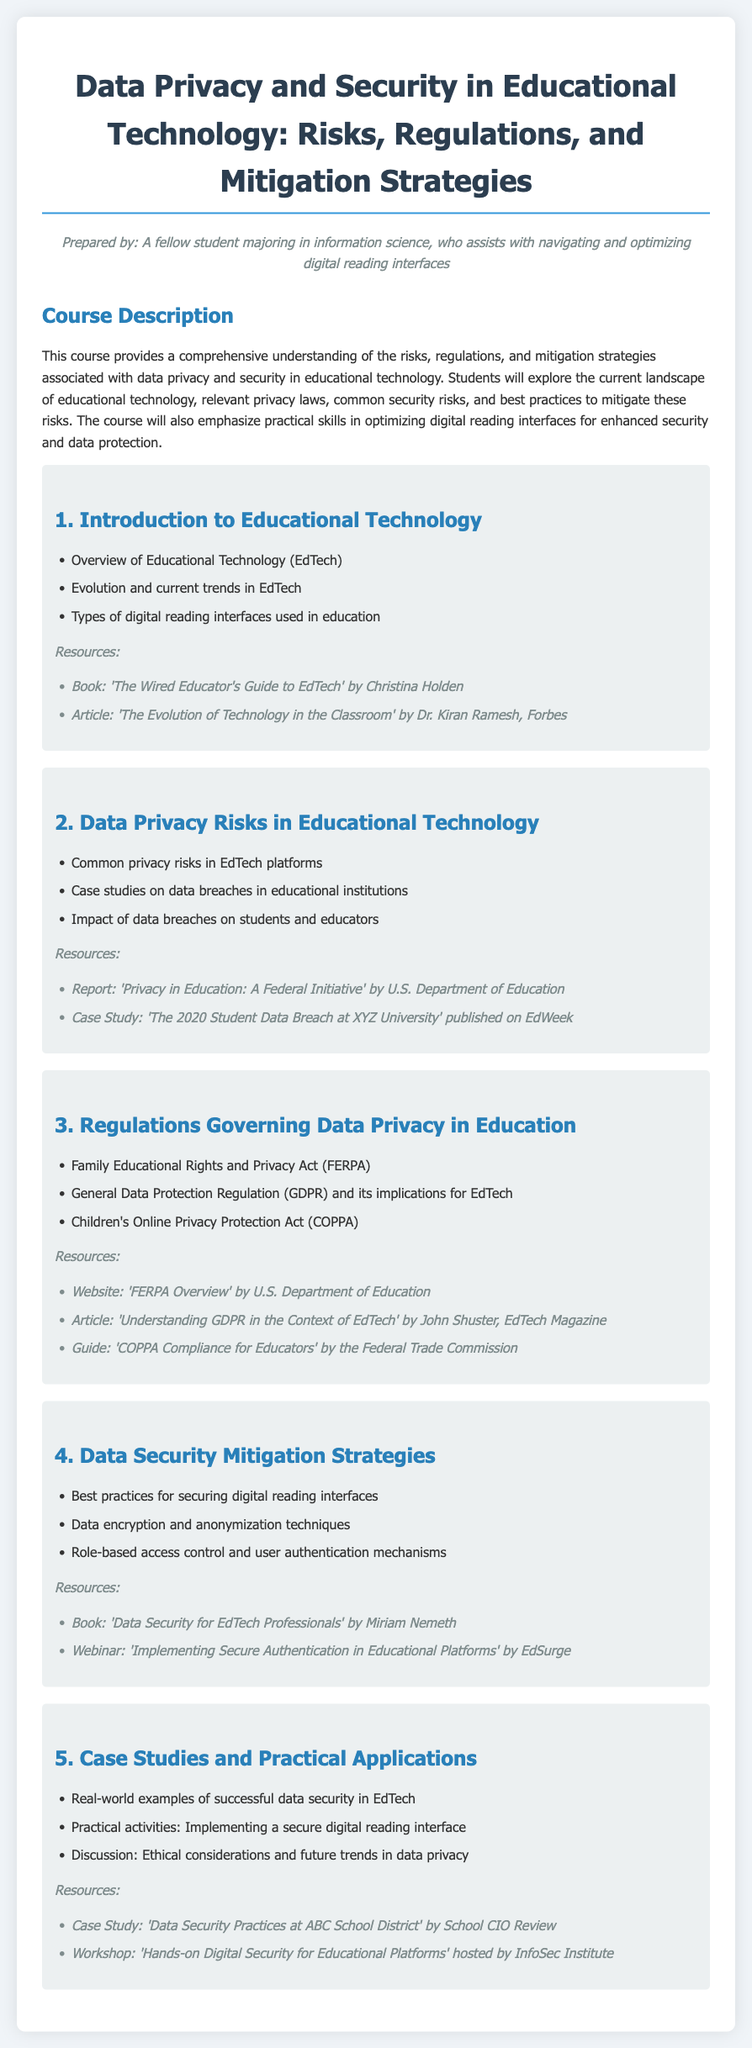What is the course title? The course title is explicitly mentioned as the heading of the document.
Answer: Data Privacy and Security in Educational Technology: Risks, Regulations, and Mitigation Strategies What is the first topic covered in the syllabus? The first topic is listed under the sections in the syllabus, outlining the main subjects of study.
Answer: Introduction to Educational Technology What legislation is mentioned concerning data privacy in education? The syllabus outlines relevant regulations in a specific section, indicating key legal frameworks.
Answer: Family Educational Rights and Privacy Act (FERPA) How many main sections are provided in the syllabus? Counting the main sections outlined, we can determine the total number of categories covered in the document.
Answer: Five Which resource is listed for the case studies and practical applications section? The resource section lists specific materials related to each main topic area.
Answer: Case Study: 'Data Security Practices at ABC School District' by School CIO Review What does the course focus on enhancing in digital reading interfaces? The course description highlights specific skills that will be developed related to digital reading platforms.
Answer: Security and data protection 